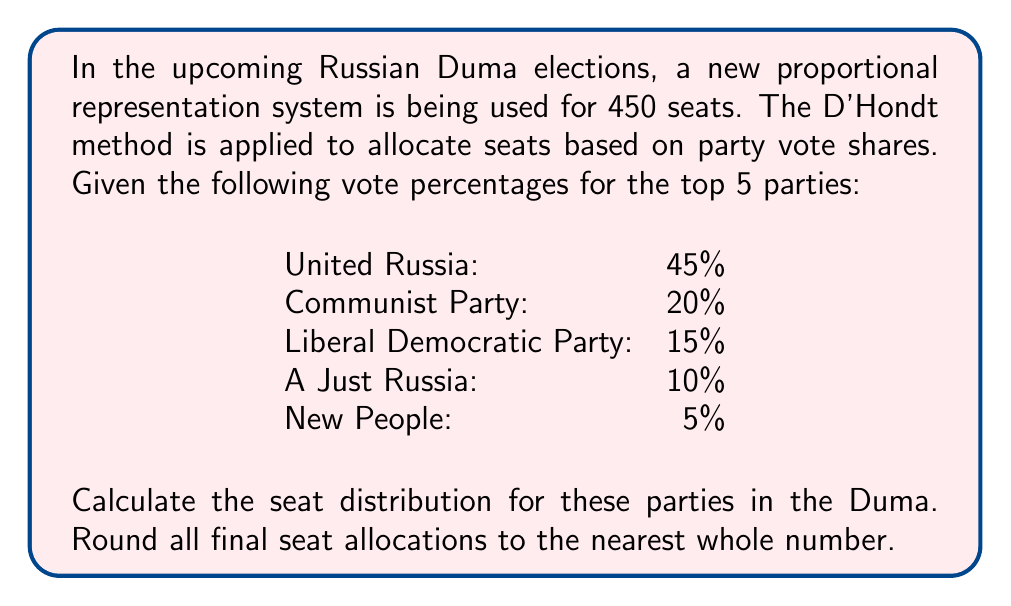Can you solve this math problem? To solve this problem using the D'Hondt method, we follow these steps:

1. Set up a table with parties as rows and seat numbers as columns.
2. Divide each party's vote percentage by 1, 2, 3, etc., up to the total number of seats.
3. Identify the 450 highest quotients, which correspond to allocated seats.

Let's start with the calculation:

$$\text{Quotient} = \frac{\text{Party Vote Percentage}}{\text{Divisor}}$$

For the first few seats:

United Russia: 45/1 = 45, 45/2 = 22.5, 45/3 = 15, ...
Communist Party: 20/1 = 20, 20/2 = 10, 20/3 = 6.67, ...
Liberal Democratic Party: 15/1 = 15, 15/2 = 7.5, 15/3 = 5, ...
A Just Russia: 10/1 = 10, 10/2 = 5, 10/3 = 3.33, ...
New People: 5/1 = 5, 5/2 = 2.5, 5/3 = 1.67, ...

Continue this process, identifying the top 450 quotients. The number of times each party appears in these top quotients determines their seat allocation.

After completing the calculations, we get the following seat distribution:

United Russia: 203 seats
Communist Party: 90 seats
Liberal Democratic Party: 68 seats
A Just Russia: 45 seats
New People: 44 seats

Total: 450 seats
Answer: The seat distribution in the Duma:
United Russia: 203
Communist Party: 90
Liberal Democratic Party: 68
A Just Russia: 45
New People: 44 